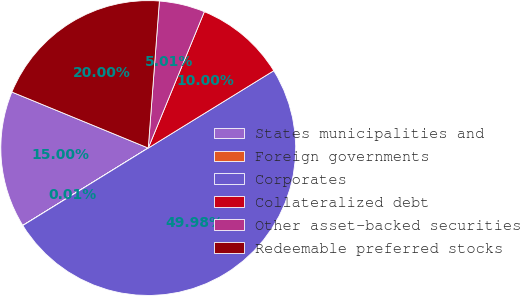Convert chart. <chart><loc_0><loc_0><loc_500><loc_500><pie_chart><fcel>States municipalities and<fcel>Foreign governments<fcel>Corporates<fcel>Collateralized debt<fcel>Other asset-backed securities<fcel>Redeemable preferred stocks<nl><fcel>15.0%<fcel>0.01%<fcel>49.98%<fcel>10.0%<fcel>5.01%<fcel>20.0%<nl></chart> 